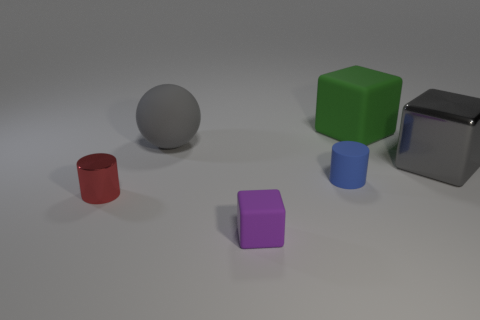Add 3 big gray matte balls. How many objects exist? 9 Subtract all cylinders. How many objects are left? 4 Subtract 0 green cylinders. How many objects are left? 6 Subtract all large purple shiny blocks. Subtract all large gray metallic cubes. How many objects are left? 5 Add 5 big gray blocks. How many big gray blocks are left? 6 Add 2 purple rubber blocks. How many purple rubber blocks exist? 3 